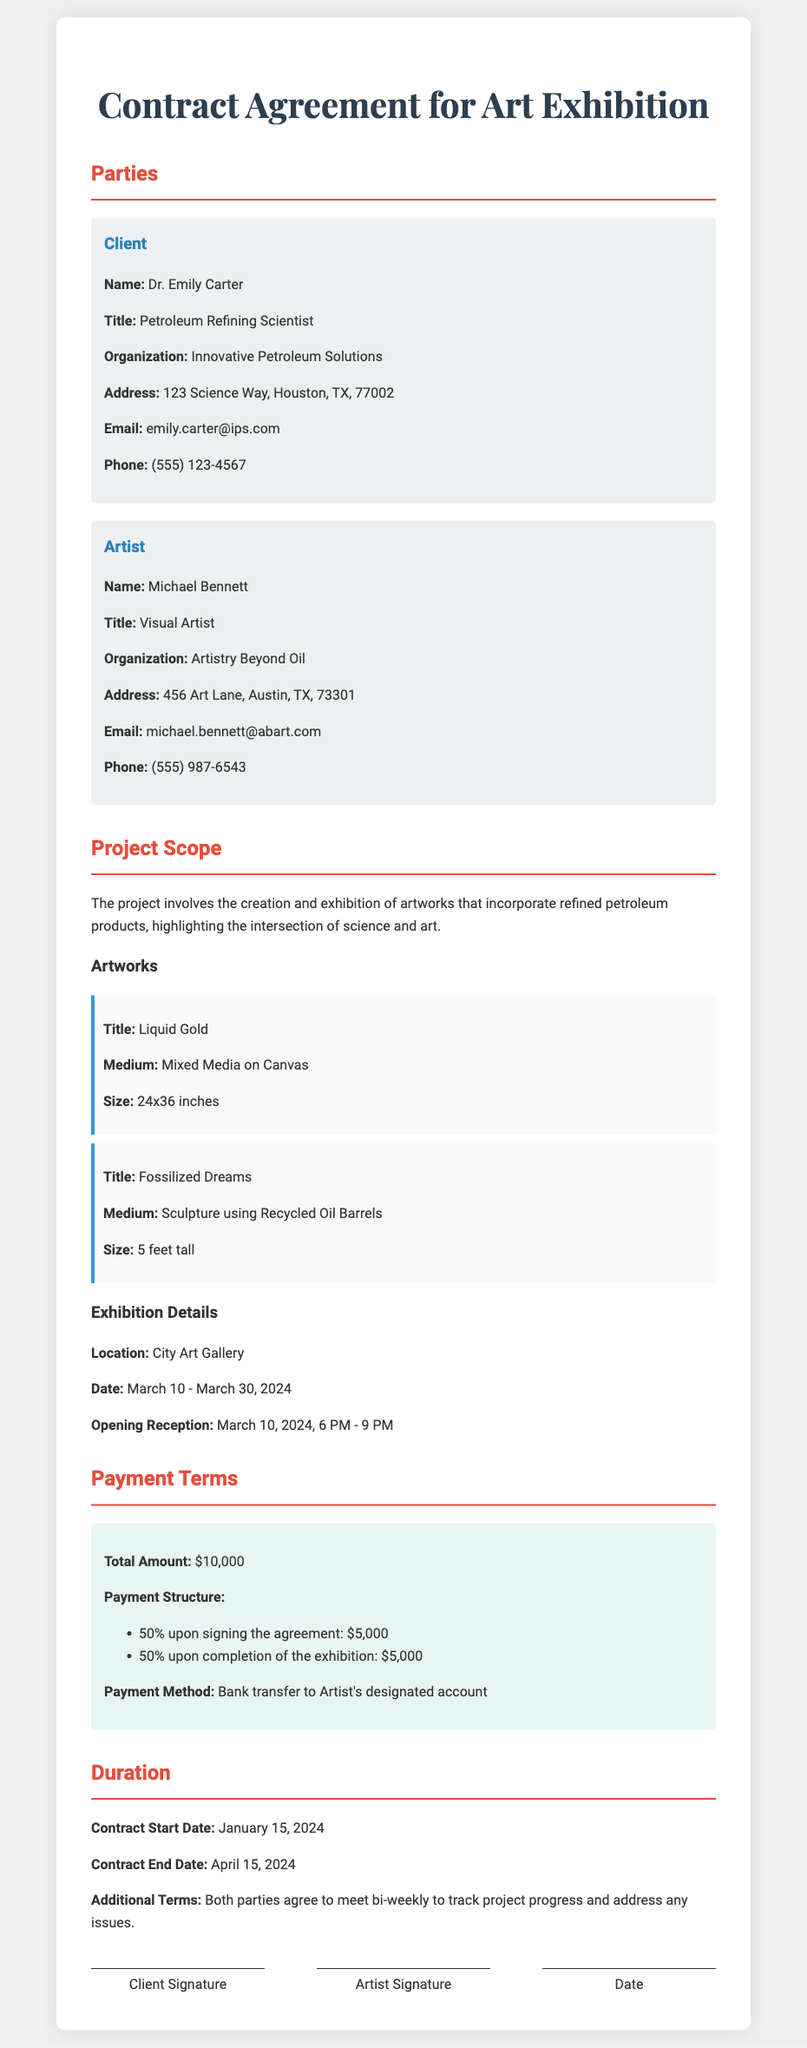What is the name of the client? The client's name is listed in the document as Dr. Emily Carter.
Answer: Dr. Emily Carter What is the total amount for the project? The total payment amount specified in the document is $10,000.
Answer: $10,000 What is the opening reception date? The document specifies the opening reception date as March 10, 2024.
Answer: March 10, 2024 What is the payment structure for the agreement? The payment structure indicates two payments of 50%: one upon signing and one upon completion.
Answer: 50% upon signing, 50% upon completion How long is the duration of the contract? The contract starts on January 15, 2024, and ends on April 15, 2024, giving a duration of 3 months.
Answer: 3 months What is the title of the sculpture artwork? The document identifies the sculpture's title as "Fossilized Dreams."
Answer: Fossilized Dreams What organization does the artist belong to? The artist's organization mentioned in the document is Artistry Beyond Oil.
Answer: Artistry Beyond Oil Where will the exhibition take place? The exhibition is scheduled to take place at the City Art Gallery.
Answer: City Art Gallery 